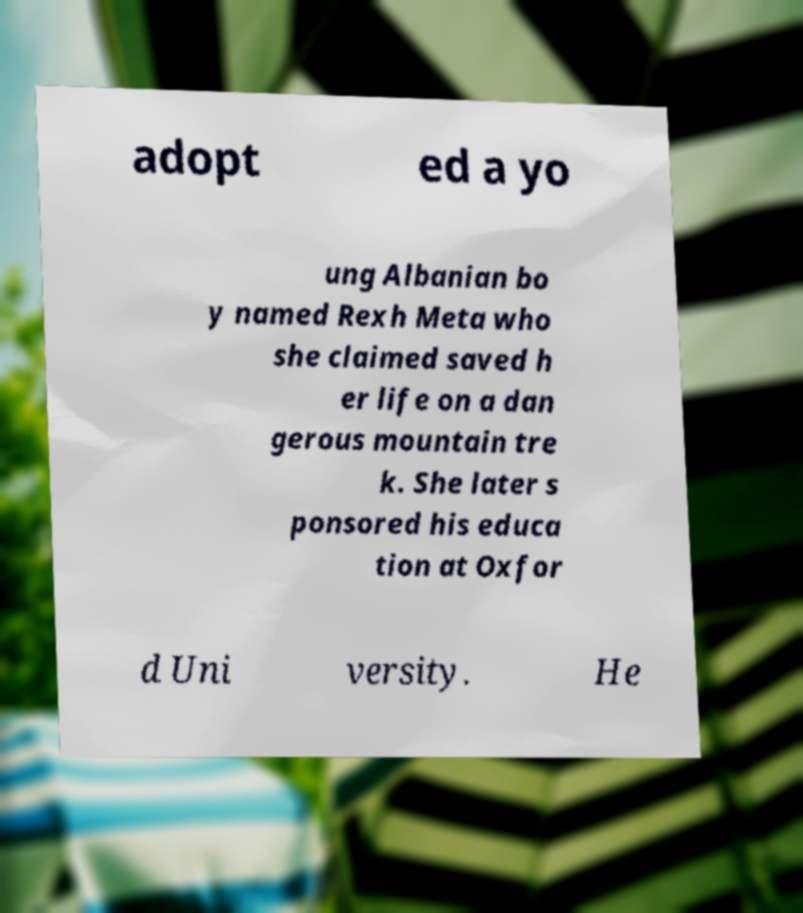I need the written content from this picture converted into text. Can you do that? adopt ed a yo ung Albanian bo y named Rexh Meta who she claimed saved h er life on a dan gerous mountain tre k. She later s ponsored his educa tion at Oxfor d Uni versity. He 